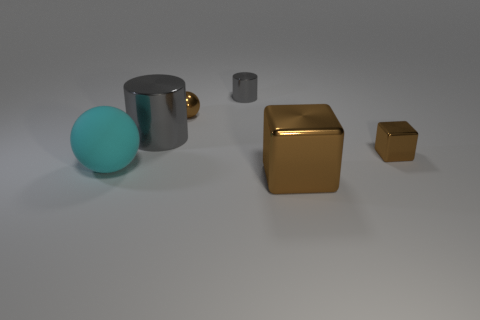How many metallic objects are either yellow things or large cylinders? In the image, there appears to be one large metallic cylinder, which is the silver mug. Although there are two yellow objects, one box and one smaller item, they aren't cylinders. Therefore, according to the original question's criteria, the count of metallic objects that are either yellow or large cylinders is one. 